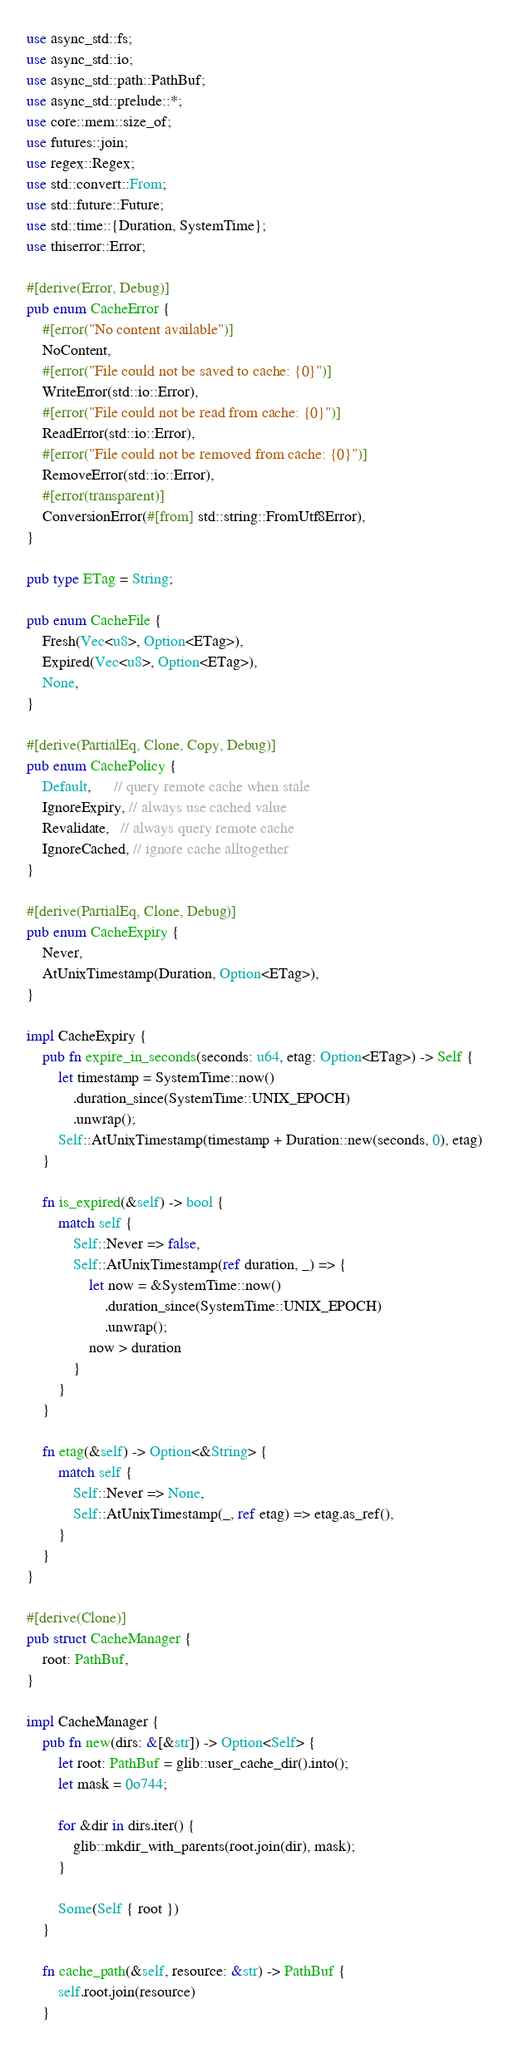<code> <loc_0><loc_0><loc_500><loc_500><_Rust_>use async_std::fs;
use async_std::io;
use async_std::path::PathBuf;
use async_std::prelude::*;
use core::mem::size_of;
use futures::join;
use regex::Regex;
use std::convert::From;
use std::future::Future;
use std::time::{Duration, SystemTime};
use thiserror::Error;

#[derive(Error, Debug)]
pub enum CacheError {
    #[error("No content available")]
    NoContent,
    #[error("File could not be saved to cache: {0}")]
    WriteError(std::io::Error),
    #[error("File could not be read from cache: {0}")]
    ReadError(std::io::Error),
    #[error("File could not be removed from cache: {0}")]
    RemoveError(std::io::Error),
    #[error(transparent)]
    ConversionError(#[from] std::string::FromUtf8Error),
}

pub type ETag = String;

pub enum CacheFile {
    Fresh(Vec<u8>, Option<ETag>),
    Expired(Vec<u8>, Option<ETag>),
    None,
}

#[derive(PartialEq, Clone, Copy, Debug)]
pub enum CachePolicy {
    Default,      // query remote cache when stale
    IgnoreExpiry, // always use cached value
    Revalidate,   // always query remote cache
    IgnoreCached, // ignore cache alltogether
}

#[derive(PartialEq, Clone, Debug)]
pub enum CacheExpiry {
    Never,
    AtUnixTimestamp(Duration, Option<ETag>),
}

impl CacheExpiry {
    pub fn expire_in_seconds(seconds: u64, etag: Option<ETag>) -> Self {
        let timestamp = SystemTime::now()
            .duration_since(SystemTime::UNIX_EPOCH)
            .unwrap();
        Self::AtUnixTimestamp(timestamp + Duration::new(seconds, 0), etag)
    }

    fn is_expired(&self) -> bool {
        match self {
            Self::Never => false,
            Self::AtUnixTimestamp(ref duration, _) => {
                let now = &SystemTime::now()
                    .duration_since(SystemTime::UNIX_EPOCH)
                    .unwrap();
                now > duration
            }
        }
    }

    fn etag(&self) -> Option<&String> {
        match self {
            Self::Never => None,
            Self::AtUnixTimestamp(_, ref etag) => etag.as_ref(),
        }
    }
}

#[derive(Clone)]
pub struct CacheManager {
    root: PathBuf,
}

impl CacheManager {
    pub fn new(dirs: &[&str]) -> Option<Self> {
        let root: PathBuf = glib::user_cache_dir().into();
        let mask = 0o744;

        for &dir in dirs.iter() {
            glib::mkdir_with_parents(root.join(dir), mask);
        }

        Some(Self { root })
    }

    fn cache_path(&self, resource: &str) -> PathBuf {
        self.root.join(resource)
    }
</code> 